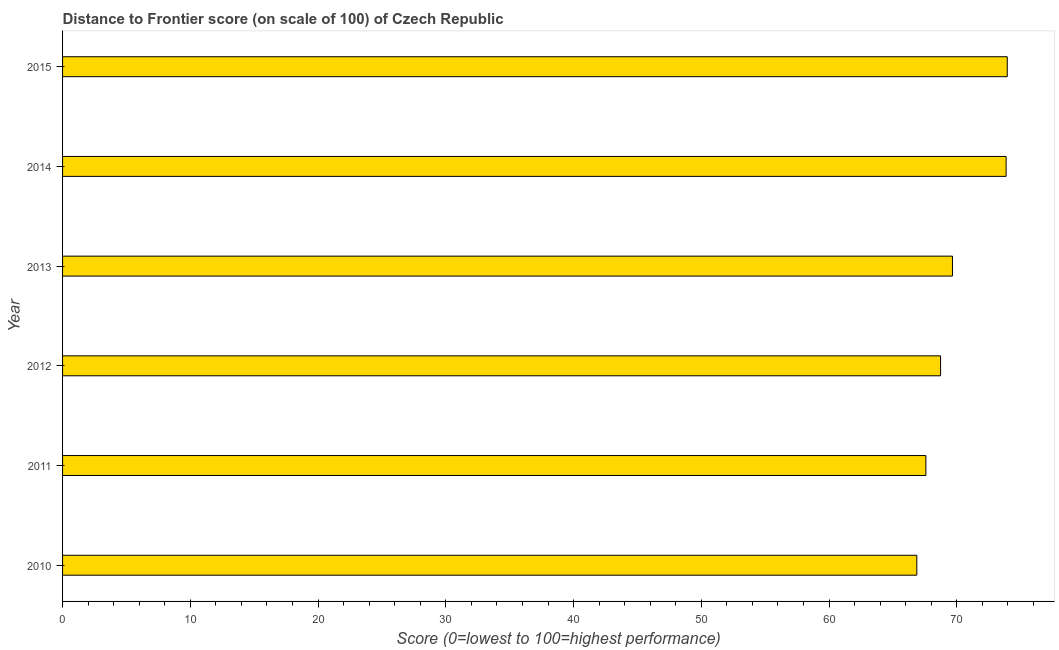Does the graph contain any zero values?
Offer a terse response. No. Does the graph contain grids?
Your answer should be very brief. No. What is the title of the graph?
Offer a very short reply. Distance to Frontier score (on scale of 100) of Czech Republic. What is the label or title of the X-axis?
Offer a very short reply. Score (0=lowest to 100=highest performance). What is the distance to frontier score in 2012?
Give a very brief answer. 68.73. Across all years, what is the maximum distance to frontier score?
Your answer should be very brief. 73.95. Across all years, what is the minimum distance to frontier score?
Your answer should be very brief. 66.87. In which year was the distance to frontier score maximum?
Make the answer very short. 2015. In which year was the distance to frontier score minimum?
Provide a short and direct response. 2010. What is the sum of the distance to frontier score?
Provide a short and direct response. 420.65. What is the difference between the distance to frontier score in 2014 and 2015?
Your answer should be very brief. -0.09. What is the average distance to frontier score per year?
Provide a succinct answer. 70.11. What is the median distance to frontier score?
Give a very brief answer. 69.19. What is the difference between the highest and the second highest distance to frontier score?
Provide a succinct answer. 0.09. What is the difference between the highest and the lowest distance to frontier score?
Give a very brief answer. 7.08. How many bars are there?
Keep it short and to the point. 6. Are all the bars in the graph horizontal?
Your answer should be compact. Yes. Are the values on the major ticks of X-axis written in scientific E-notation?
Your response must be concise. No. What is the Score (0=lowest to 100=highest performance) in 2010?
Provide a short and direct response. 66.87. What is the Score (0=lowest to 100=highest performance) in 2011?
Provide a succinct answer. 67.58. What is the Score (0=lowest to 100=highest performance) in 2012?
Ensure brevity in your answer.  68.73. What is the Score (0=lowest to 100=highest performance) in 2013?
Make the answer very short. 69.66. What is the Score (0=lowest to 100=highest performance) of 2014?
Your answer should be compact. 73.86. What is the Score (0=lowest to 100=highest performance) of 2015?
Provide a short and direct response. 73.95. What is the difference between the Score (0=lowest to 100=highest performance) in 2010 and 2011?
Ensure brevity in your answer.  -0.71. What is the difference between the Score (0=lowest to 100=highest performance) in 2010 and 2012?
Provide a short and direct response. -1.86. What is the difference between the Score (0=lowest to 100=highest performance) in 2010 and 2013?
Your answer should be compact. -2.79. What is the difference between the Score (0=lowest to 100=highest performance) in 2010 and 2014?
Your response must be concise. -6.99. What is the difference between the Score (0=lowest to 100=highest performance) in 2010 and 2015?
Make the answer very short. -7.08. What is the difference between the Score (0=lowest to 100=highest performance) in 2011 and 2012?
Offer a very short reply. -1.15. What is the difference between the Score (0=lowest to 100=highest performance) in 2011 and 2013?
Ensure brevity in your answer.  -2.08. What is the difference between the Score (0=lowest to 100=highest performance) in 2011 and 2014?
Provide a succinct answer. -6.28. What is the difference between the Score (0=lowest to 100=highest performance) in 2011 and 2015?
Offer a very short reply. -6.37. What is the difference between the Score (0=lowest to 100=highest performance) in 2012 and 2013?
Your response must be concise. -0.93. What is the difference between the Score (0=lowest to 100=highest performance) in 2012 and 2014?
Offer a very short reply. -5.13. What is the difference between the Score (0=lowest to 100=highest performance) in 2012 and 2015?
Your answer should be very brief. -5.22. What is the difference between the Score (0=lowest to 100=highest performance) in 2013 and 2015?
Offer a terse response. -4.29. What is the difference between the Score (0=lowest to 100=highest performance) in 2014 and 2015?
Your response must be concise. -0.09. What is the ratio of the Score (0=lowest to 100=highest performance) in 2010 to that in 2011?
Give a very brief answer. 0.99. What is the ratio of the Score (0=lowest to 100=highest performance) in 2010 to that in 2012?
Your answer should be very brief. 0.97. What is the ratio of the Score (0=lowest to 100=highest performance) in 2010 to that in 2013?
Make the answer very short. 0.96. What is the ratio of the Score (0=lowest to 100=highest performance) in 2010 to that in 2014?
Provide a succinct answer. 0.91. What is the ratio of the Score (0=lowest to 100=highest performance) in 2010 to that in 2015?
Provide a short and direct response. 0.9. What is the ratio of the Score (0=lowest to 100=highest performance) in 2011 to that in 2014?
Ensure brevity in your answer.  0.92. What is the ratio of the Score (0=lowest to 100=highest performance) in 2011 to that in 2015?
Offer a very short reply. 0.91. What is the ratio of the Score (0=lowest to 100=highest performance) in 2012 to that in 2015?
Keep it short and to the point. 0.93. What is the ratio of the Score (0=lowest to 100=highest performance) in 2013 to that in 2014?
Make the answer very short. 0.94. What is the ratio of the Score (0=lowest to 100=highest performance) in 2013 to that in 2015?
Your response must be concise. 0.94. 